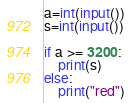Convert code to text. <code><loc_0><loc_0><loc_500><loc_500><_Python_>a=int(input())
s=int(input())

if a >= 3200:
    print(s)
else:
    print("red")</code> 